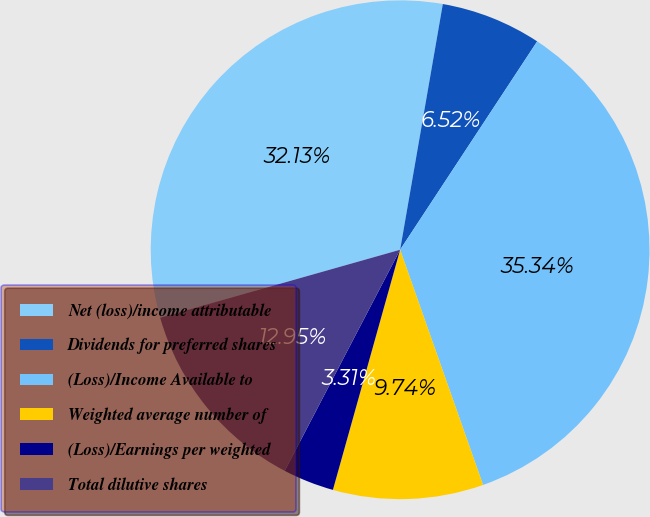Convert chart to OTSL. <chart><loc_0><loc_0><loc_500><loc_500><pie_chart><fcel>Net (loss)/income attributable<fcel>Dividends for preferred shares<fcel>(Loss)/Income Available to<fcel>Weighted average number of<fcel>(Loss)/Earnings per weighted<fcel>Total dilutive shares<nl><fcel>32.13%<fcel>6.52%<fcel>35.34%<fcel>9.74%<fcel>3.31%<fcel>12.95%<nl></chart> 